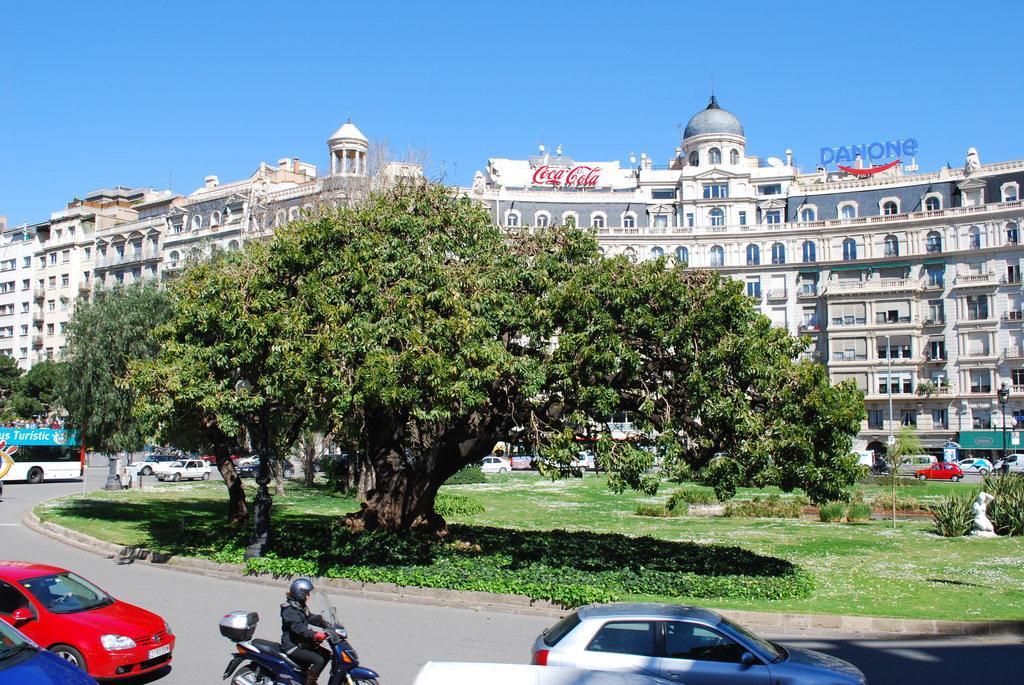In one or two sentences, can you explain what this image depicts? There is a road. On that there are many vehicle. In the back there are trees, plants and grass lawn. In the background there is a building with windows and name boards on that. Also there is sky in the background. 